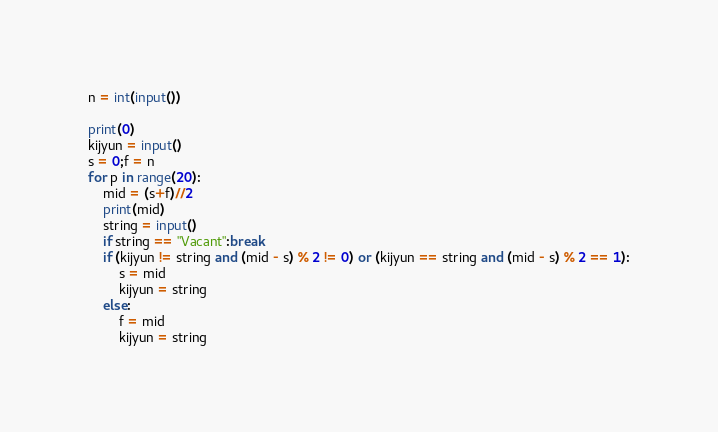<code> <loc_0><loc_0><loc_500><loc_500><_Python_>n = int(input())

print(0)
kijyun = input()
s = 0;f = n
for p in range(20):
    mid = (s+f)//2
    print(mid)
    string = input()
    if string == "Vacant":break
    if (kijyun != string and (mid - s) % 2 != 0) or (kijyun == string and (mid - s) % 2 == 1):
        s = mid
        kijyun = string
    else:
        f = mid
        kijyun = string
</code> 